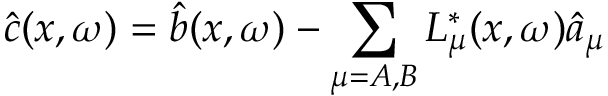Convert formula to latex. <formula><loc_0><loc_0><loc_500><loc_500>\hat { c } ( x , \omega ) = \hat { b } ( x , \omega ) - \sum _ { \mu = A , B } L _ { \mu } ^ { * } ( x , \omega ) \hat { a } _ { \mu }</formula> 